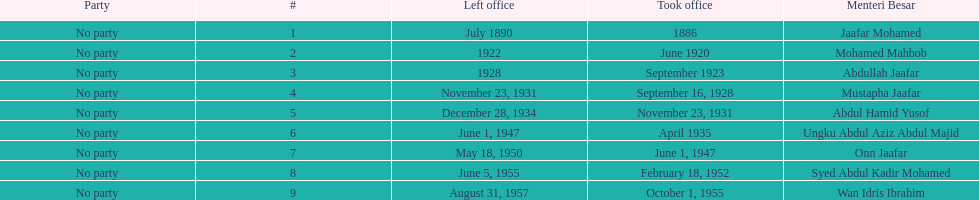Who took office after onn jaafar? Syed Abdul Kadir Mohamed. 